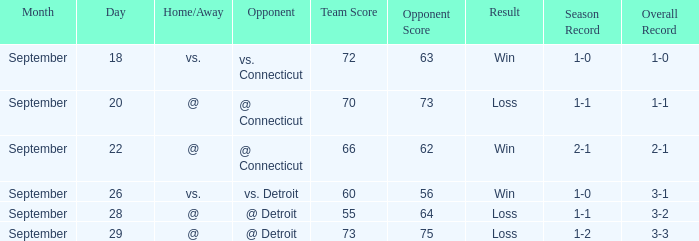WHAT IS THE OPPONENT WITH A SCORE OF 72-63? Vs. connecticut. Help me parse the entirety of this table. {'header': ['Month', 'Day', 'Home/Away', 'Opponent', 'Team Score', 'Opponent Score', 'Result', 'Season Record', 'Overall Record'], 'rows': [['September', '18', 'vs.', 'vs. Connecticut', '72', '63', 'Win', '1-0', '1-0'], ['September', '20', '@', '@ Connecticut', '70', '73', 'Loss', '1-1', '1-1'], ['September', '22', '@', '@ Connecticut', '66', '62', 'Win', '2-1', '2-1'], ['September', '26', 'vs.', 'vs. Detroit', '60', '56', 'Win', '1-0', '3-1'], ['September', '28', '@', '@ Detroit', '55', '64', 'Loss', '1-1', '3-2'], ['September', '29', '@', '@ Detroit', '73', '75', 'Loss', '1-2', '3-3']]} 